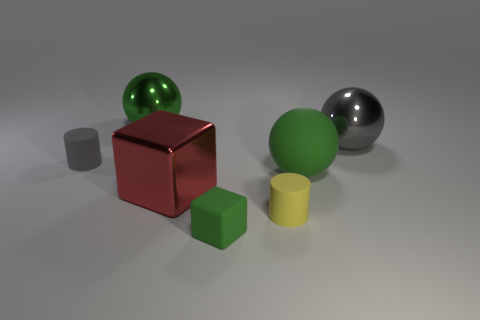Subtract all green spheres. How many spheres are left? 1 Add 2 big green balls. How many objects exist? 9 Subtract all gray spheres. How many spheres are left? 2 Subtract all purple cylinders. How many cyan cubes are left? 0 Subtract all balls. How many objects are left? 4 Subtract 2 spheres. How many spheres are left? 1 Add 4 red shiny blocks. How many red shiny blocks exist? 5 Subtract 0 yellow spheres. How many objects are left? 7 Subtract all gray cylinders. Subtract all cyan balls. How many cylinders are left? 1 Subtract all large shiny spheres. Subtract all small cyan cylinders. How many objects are left? 5 